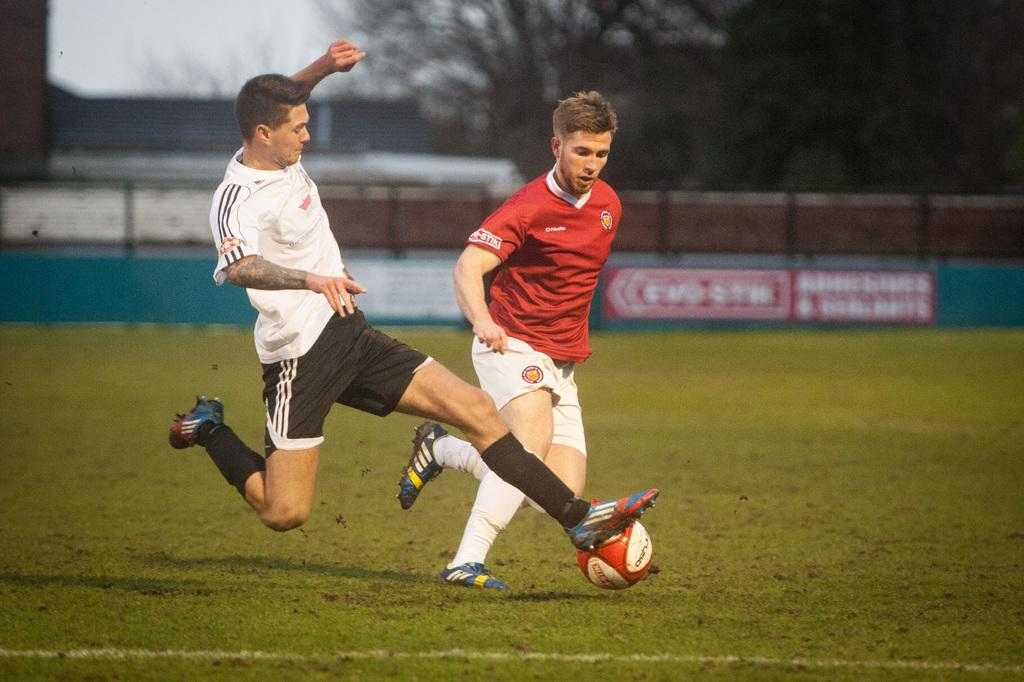What type of vegetation can be seen in the image? There are trees in the image. What structure is present in the image? There is a fence in the image. What additional object is visible in the image? There is a banner in the image. What activity are two people engaged in within the image? Two people are playing with a ball in the image. What type of railway can be seen in the image? There is no railway present in the image. How does the banner express anger in the image? The banner does not express anger in the image; it is simply a visual object. 